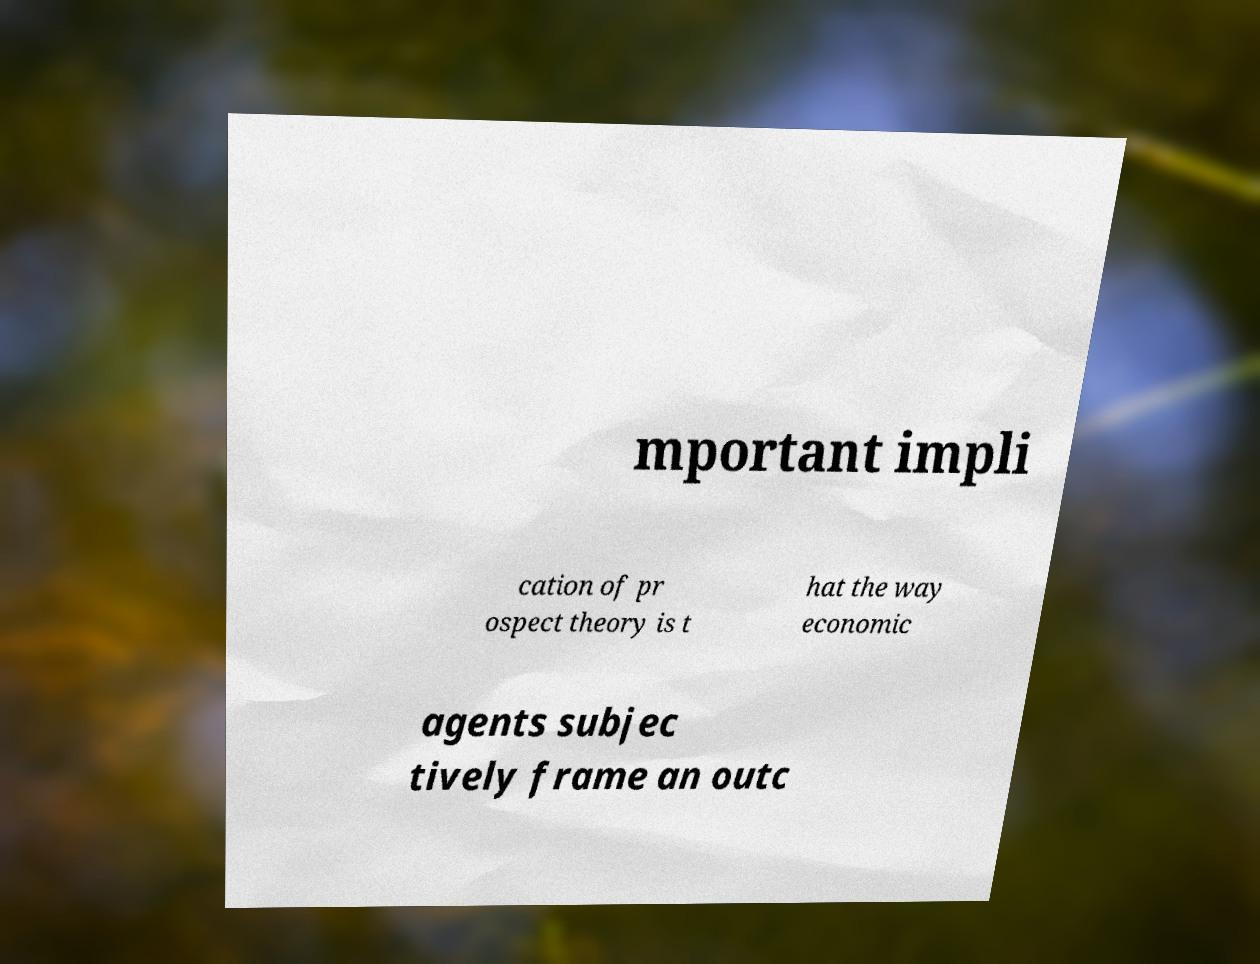What messages or text are displayed in this image? I need them in a readable, typed format. mportant impli cation of pr ospect theory is t hat the way economic agents subjec tively frame an outc 